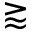<formula> <loc_0><loc_0><loc_500><loc_500>\gtrapprox</formula> 